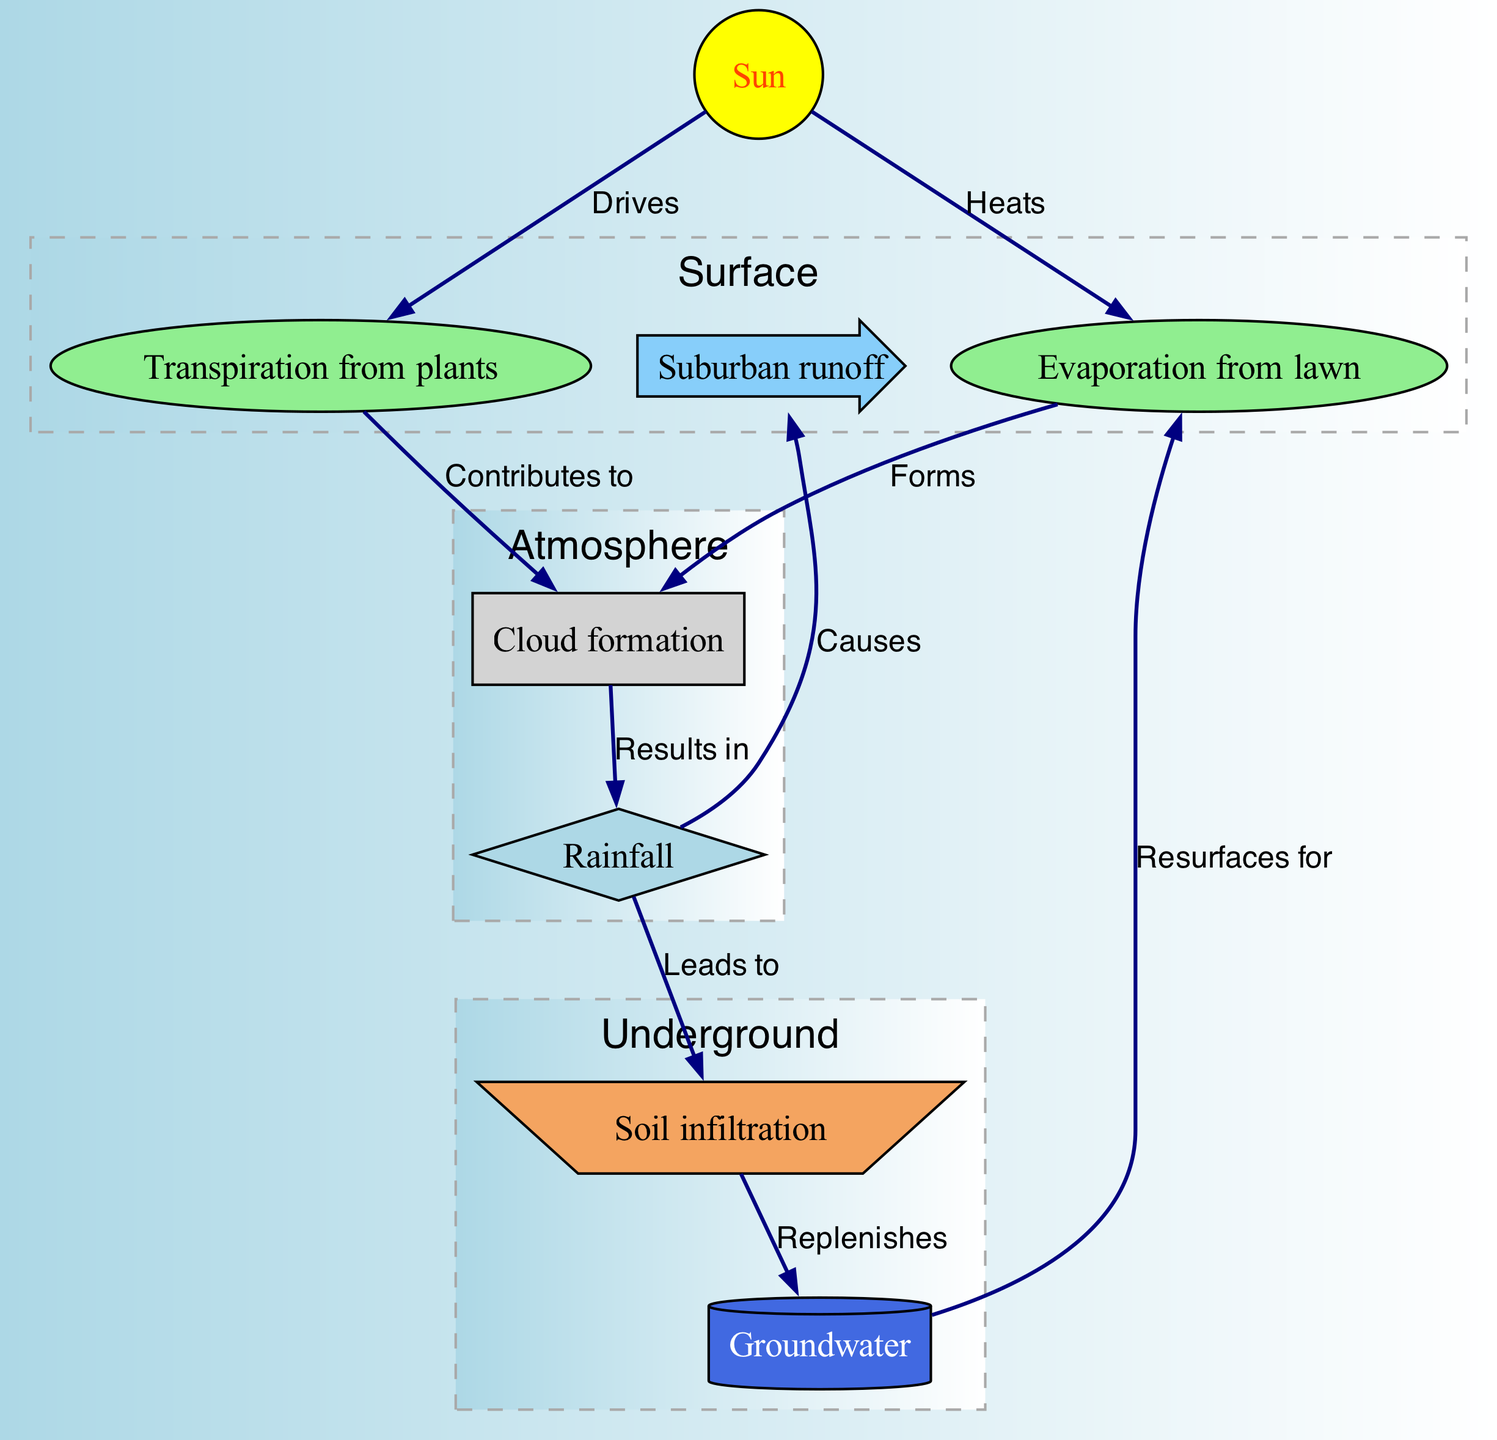What forms clouds in the water cycle? According to the diagram, both evaporation from the lawn and transpiration from plants contribute to cloud formation. The diagram arrows show that evaporation leads to clouds and transpiration also contributes to clouds.
Answer: Evaporation and transpiration What is the shape of the groundwater node? The diagram specifies the shape of the groundwater node as a cylinder, which is a clear representation in the design.
Answer: Cylinder How many processes are involved in the water cycle as depicted in the diagram? The diagram lists eight nodes, each representing a process or component of the water cycle. Counting the nodes shows there are eight processes.
Answer: Eight What leads to rainfall in the diagram? The diagram shows clouds resulting from evaporation and transpiration, and these clouds lead to precipitation (rainfall). Thus, it is the clouds that lead to rainfall.
Answer: Clouds What causes suburban runoff as inferred from the diagram? The diagram indicates that precipitation causes runoff in suburban areas. When rainfall occurs, it leads to runoff, which is represented by an arrow pointing from precipitation to runoff.
Answer: Precipitation What replenishes groundwater in the water cycle? The diagram clearly indicates that infiltration, which results from precipitation, replenishes groundwater. The arrow shows a direct flow from infiltration to groundwater.
Answer: Infiltration What directly drives transpiration from plants? Based on the diagram, transpiration from plants is directly driven by the sun, as indicated by the arrow showing the flow from the sun to the transpiration node.
Answer: Sun What results in the formation of clouds? The diagram illustrates that both evaporation and transpiration contribute to cloud formation, evidenced by arrows pointing from both nodes to the clouds node.
Answer: Evaporation and transpiration 